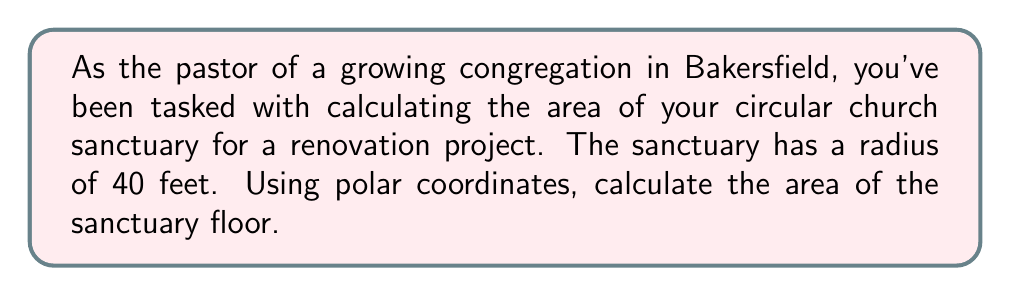Can you answer this question? To calculate the area of a circular region using polar coordinates, we can use the formula:

$$ A = \frac{1}{2} \int_{0}^{2\pi} r^2 d\theta $$

Where:
- $A$ is the area
- $r$ is the radius of the circle
- $\theta$ is the angle in radians

For a circle, the radius $r$ is constant. In this case, $r = 40$ feet.

Let's substitute the values into the formula:

$$ A = \frac{1}{2} \int_{0}^{2\pi} 40^2 d\theta $$

Simplify:

$$ A = \frac{1}{2} \cdot 1600 \int_{0}^{2\pi} d\theta $$

Evaluate the integral:

$$ A = 800 \cdot [\theta]_{0}^{2\pi} = 800 \cdot (2\pi - 0) = 1600\pi $$

Therefore, the area of the sanctuary is $1600\pi$ square feet.

To get a numerical value, we can approximate $\pi$ to 3.14159:

$$ A \approx 1600 \cdot 3.14159 \approx 5026.54 \text{ square feet} $$

[asy]
import geometry;

size(200);
fill(circle((0,0), 40), lightgray);
draw(circle((0,0), 40));
label("40 ft", (20,0), E);
dot((0,0));
label("r = 40 ft", (28,28), NE);
[/asy]
Answer: The area of the circular church sanctuary is $1600\pi$ square feet, or approximately 5026.54 square feet. 